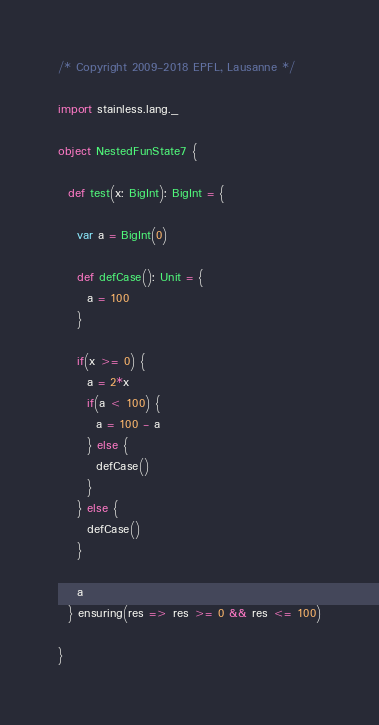Convert code to text. <code><loc_0><loc_0><loc_500><loc_500><_Scala_>/* Copyright 2009-2018 EPFL, Lausanne */

import stainless.lang._

object NestedFunState7 {

  def test(x: BigInt): BigInt = {

    var a = BigInt(0)

    def defCase(): Unit = {
      a = 100
    }

    if(x >= 0) {
      a = 2*x
      if(a < 100) {
        a = 100 - a
      } else {
        defCase()
      }
    } else {
      defCase()
    }

    a
  } ensuring(res => res >= 0 && res <= 100)

}
</code> 